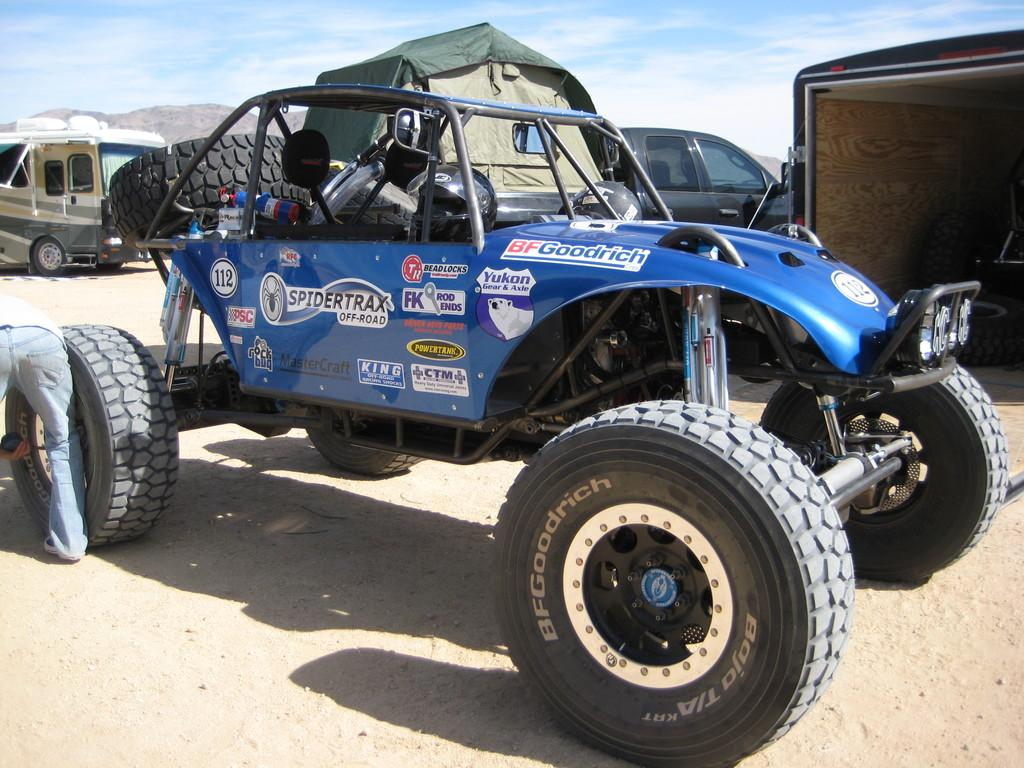What type of vehicles can be seen on the ground in the image? There are motor vehicles on the ground in the image. What can be seen in the distance behind the vehicles? There are hills visible in the background of the image. What is visible in the sky in the image? The sky is visible in the background of the image. What can be observed in the sky? Clouds are present in the sky. How many boats can be seen in the image? There are no boats present in the image. What type of destruction can be observed in the image? There is no destruction present in the image; it features motor vehicles, hills, sky, and clouds. 